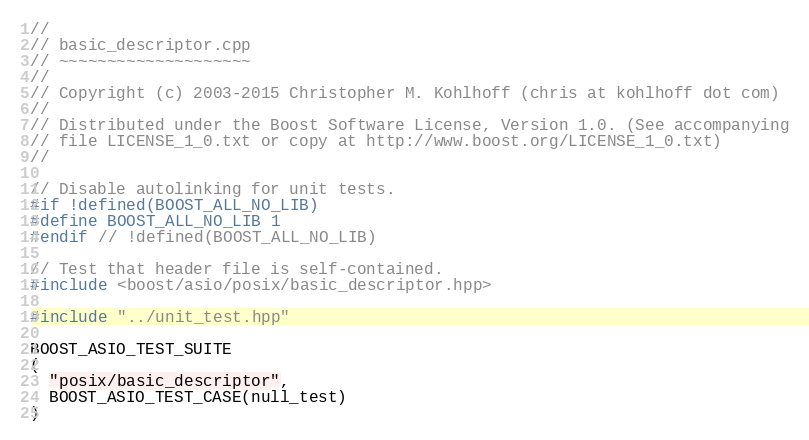Convert code to text. <code><loc_0><loc_0><loc_500><loc_500><_C++_>//
// basic_descriptor.cpp
// ~~~~~~~~~~~~~~~~~~~~
//
// Copyright (c) 2003-2015 Christopher M. Kohlhoff (chris at kohlhoff dot com)
//
// Distributed under the Boost Software License, Version 1.0. (See accompanying
// file LICENSE_1_0.txt or copy at http://www.boost.org/LICENSE_1_0.txt)
//

// Disable autolinking for unit tests.
#if !defined(BOOST_ALL_NO_LIB)
#define BOOST_ALL_NO_LIB 1
#endif // !defined(BOOST_ALL_NO_LIB)

// Test that header file is self-contained.
#include <boost/asio/posix/basic_descriptor.hpp>

#include "../unit_test.hpp"

BOOST_ASIO_TEST_SUITE
(
  "posix/basic_descriptor",
  BOOST_ASIO_TEST_CASE(null_test)
)
</code> 